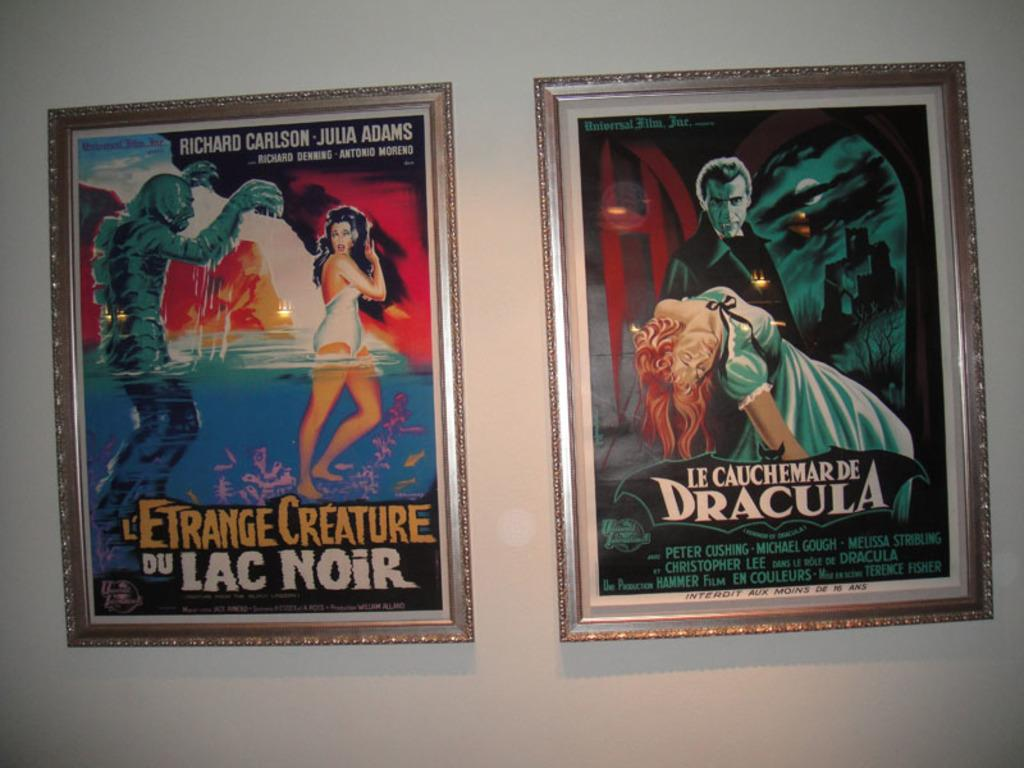<image>
Relay a brief, clear account of the picture shown. Two movie posters on a wall, one advertises the movie Le Cauchemar de Dracula. 